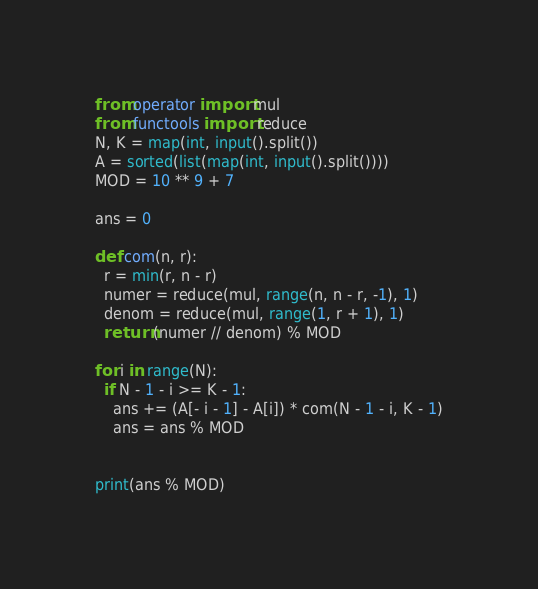Convert code to text. <code><loc_0><loc_0><loc_500><loc_500><_Python_>from operator import mul
from functools import reduce
N, K = map(int, input().split())
A = sorted(list(map(int, input().split())))
MOD = 10 ** 9 + 7

ans = 0

def com(n, r):
  r = min(r, n - r)
  numer = reduce(mul, range(n, n - r, -1), 1)
  denom = reduce(mul, range(1, r + 1), 1)
  return (numer // denom) % MOD

for i in range(N):
  if N - 1 - i >= K - 1:
    ans += (A[- i - 1] - A[i]) * com(N - 1 - i, K - 1)
    ans = ans % MOD
    
    
print(ans % MOD)
</code> 